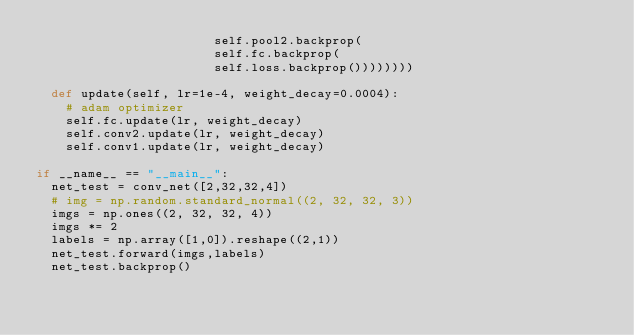<code> <loc_0><loc_0><loc_500><loc_500><_Python_>                        self.pool2.backprop(
                        self.fc.backprop(
                        self.loss.backprop())))))))

  def update(self, lr=1e-4, weight_decay=0.0004):
    # adam optimizer
    self.fc.update(lr, weight_decay)
    self.conv2.update(lr, weight_decay)
    self.conv1.update(lr, weight_decay)

if __name__ == "__main__":
  net_test = conv_net([2,32,32,4])
  # img = np.random.standard_normal((2, 32, 32, 3))
  imgs = np.ones((2, 32, 32, 4))
  imgs *= 2
  labels = np.array([1,0]).reshape((2,1))
  net_test.forward(imgs,labels)
  net_test.backprop()

</code> 